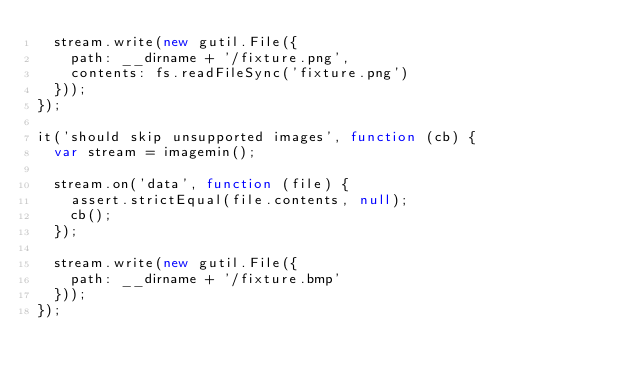<code> <loc_0><loc_0><loc_500><loc_500><_JavaScript_>	stream.write(new gutil.File({
		path: __dirname + '/fixture.png',
		contents: fs.readFileSync('fixture.png')
	}));
});

it('should skip unsupported images', function (cb) {
	var stream = imagemin();

	stream.on('data', function (file) {
		assert.strictEqual(file.contents, null);
		cb();
	});

	stream.write(new gutil.File({
		path: __dirname + '/fixture.bmp'
	}));
});
</code> 